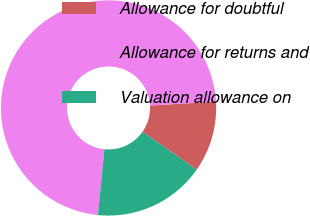Convert chart to OTSL. <chart><loc_0><loc_0><loc_500><loc_500><pie_chart><fcel>Allowance for doubtful<fcel>Allowance for returns and<fcel>Valuation allowance on<nl><fcel>10.66%<fcel>72.49%<fcel>16.85%<nl></chart> 